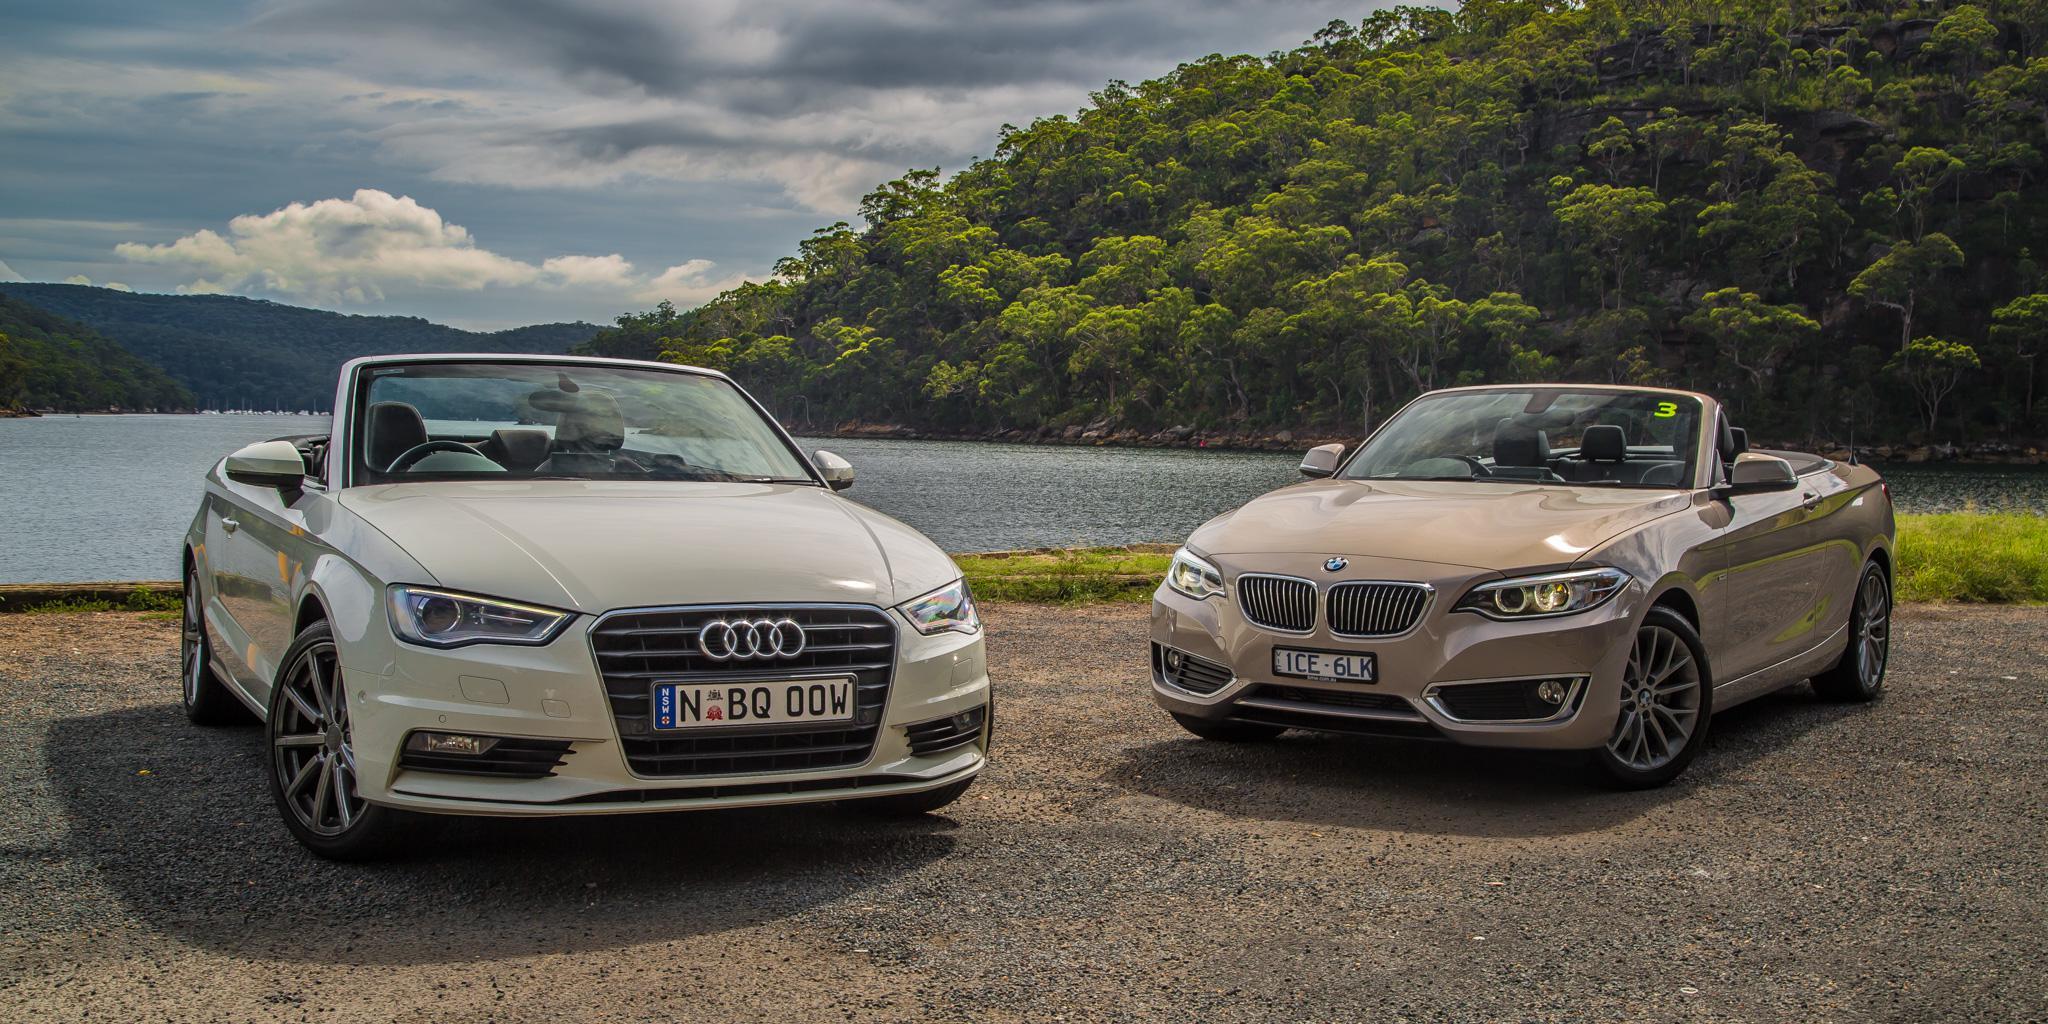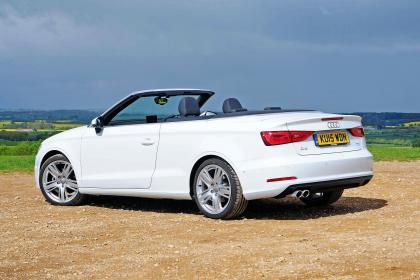The first image is the image on the left, the second image is the image on the right. Evaluate the accuracy of this statement regarding the images: "One image features a cream-colored convertible and a taupe convertible, both topless and parked in front of water.". Is it true? Answer yes or no. Yes. The first image is the image on the left, the second image is the image on the right. Given the left and right images, does the statement "The right image contains two convertible vehicles." hold true? Answer yes or no. No. 